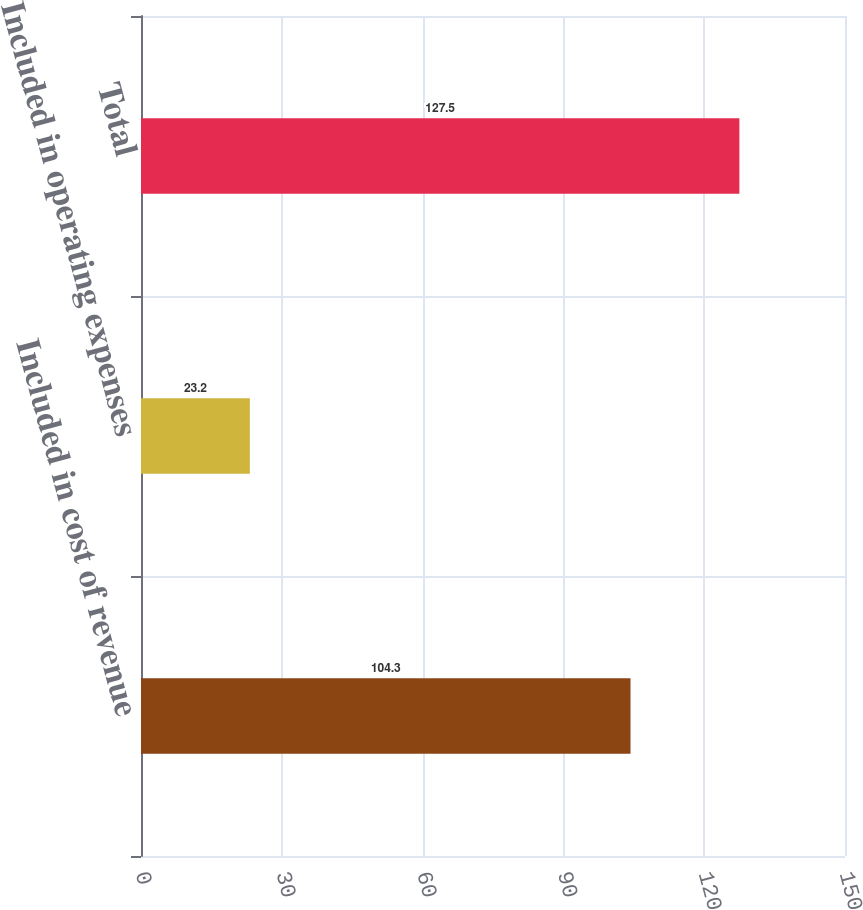<chart> <loc_0><loc_0><loc_500><loc_500><bar_chart><fcel>Included in cost of revenue<fcel>Included in operating expenses<fcel>Total<nl><fcel>104.3<fcel>23.2<fcel>127.5<nl></chart> 